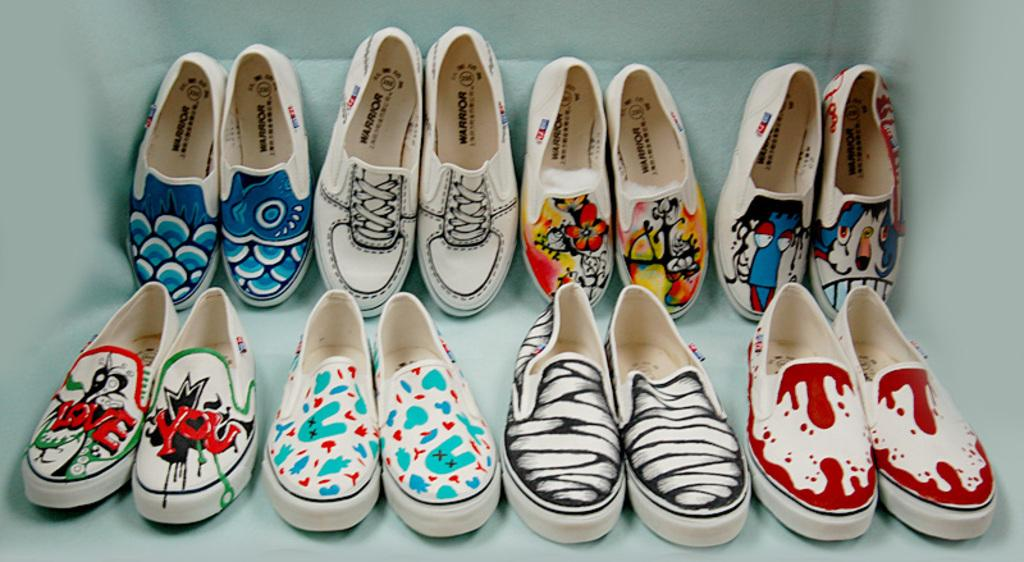What is present on the platform in the image? There is a pair of shoes on the platform in the image. What is the platform made of or designed with? The platform has a different pattern. What type of kettle can be seen boiling water on the platform in the image? There is no kettle present in the image; it only features a pair of shoes on a patterned platform. 